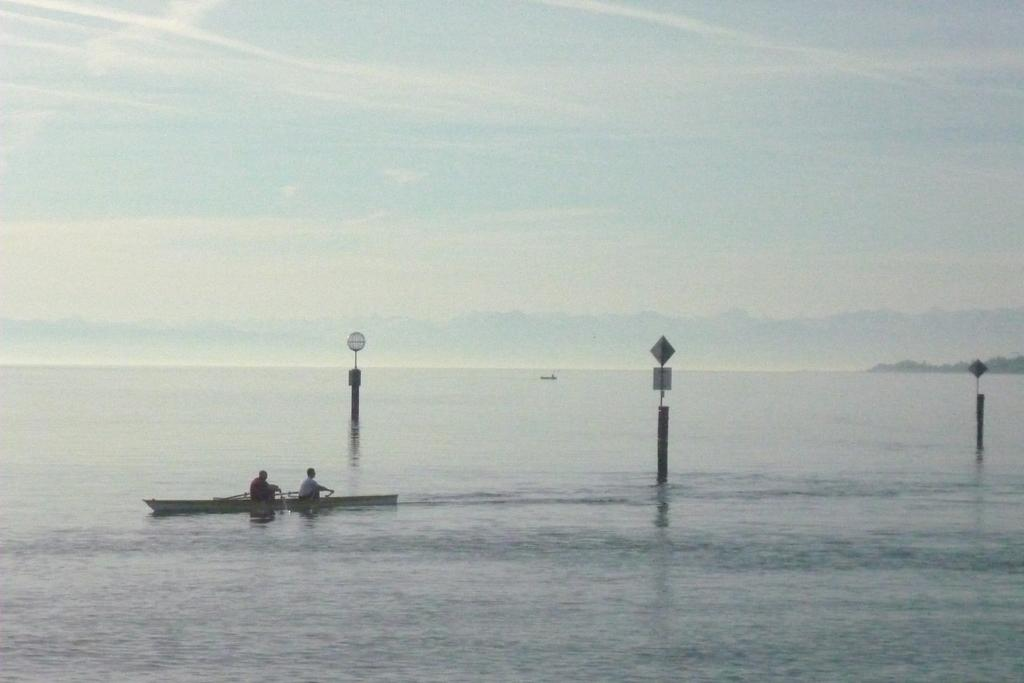What is in the water in the image? There is a boat in the water in the image. How many people are in the boat? There are two people sitting in the boat. What are the people wearing? The people are wearing clothes. What else can be seen in the image besides the boat and people? There are poles and boards visible in the image. What is the condition of the sky in the image? The sky is cloudy in the image. What type of basketball game is being played in the image? There is no basketball game present in the image; it features a boat with people in the water. What religious belief is depicted in the image? There is no religious belief depicted in the image; it features a boat with people in the water. 